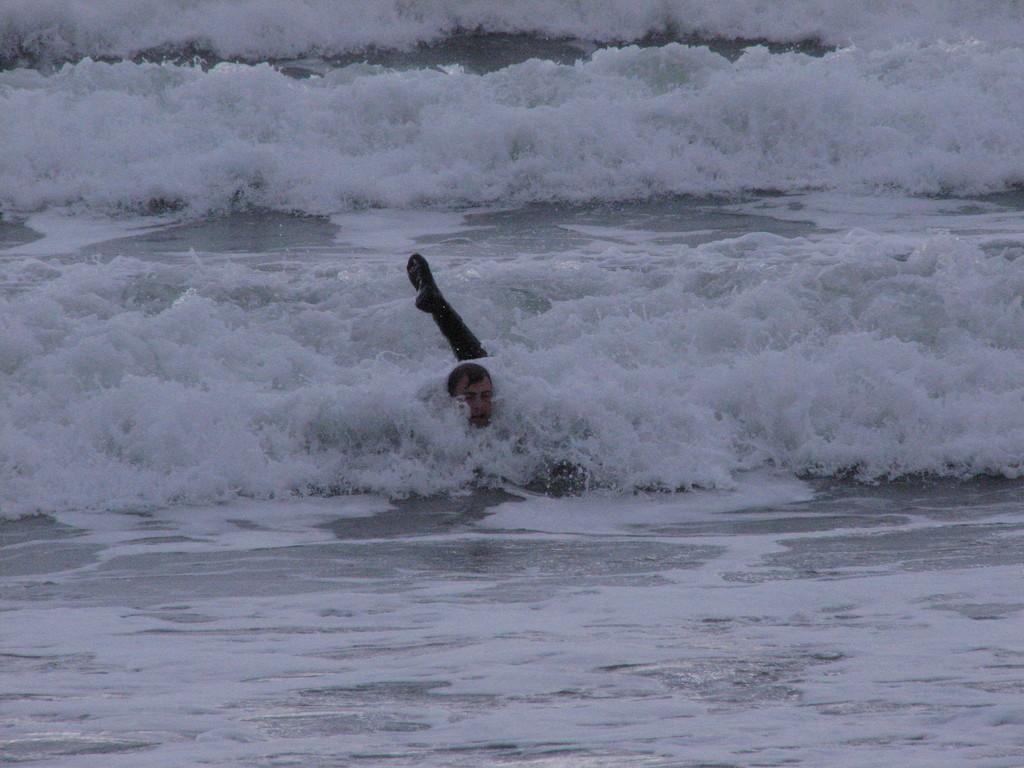What natural feature is present in the image? The image contains the sea. What can be observed about the sea in the image? There are tides visible in the sea. Is there any human presence in the image? Yes, there is a man in the water. Can you see the man holding a receipt while swimming in the image? There is no receipt visible in the image, and the man is not holding anything while swimming. 